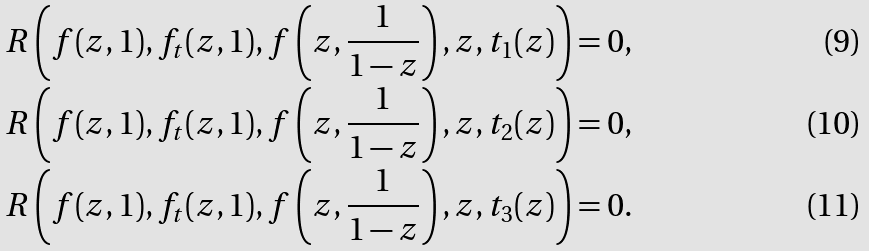<formula> <loc_0><loc_0><loc_500><loc_500>R \left ( f ( z , 1 ) , f _ { t } ( z , 1 ) , f \left ( z , \frac { 1 } { 1 - z } \right ) , z , t _ { 1 } ( z ) \right ) & = 0 , \\ R \left ( f ( z , 1 ) , f _ { t } ( z , 1 ) , f \left ( z , \frac { 1 } { 1 - z } \right ) , z , t _ { 2 } ( z ) \right ) & = 0 , \\ R \left ( f ( z , 1 ) , f _ { t } ( z , 1 ) , f \left ( z , \frac { 1 } { 1 - z } \right ) , z , t _ { 3 } ( z ) \right ) & = 0 .</formula> 